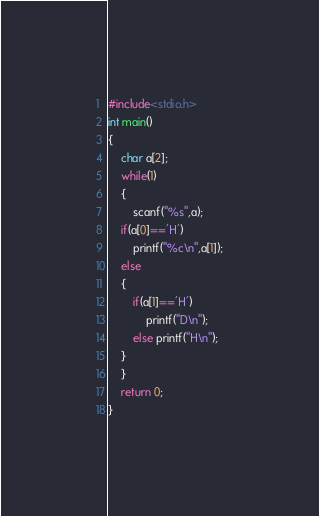<code> <loc_0><loc_0><loc_500><loc_500><_C_>#include<stdio.h>
int main()
{
    char a[2];
    while(1)
    {
        scanf("%s",a);
    if(a[0]=='H')
        printf("%c\n",a[1]);
    else
    {
        if(a[1]=='H')
            printf("D\n");
        else printf("H\n");
    }
    }
    return 0;
}
</code> 